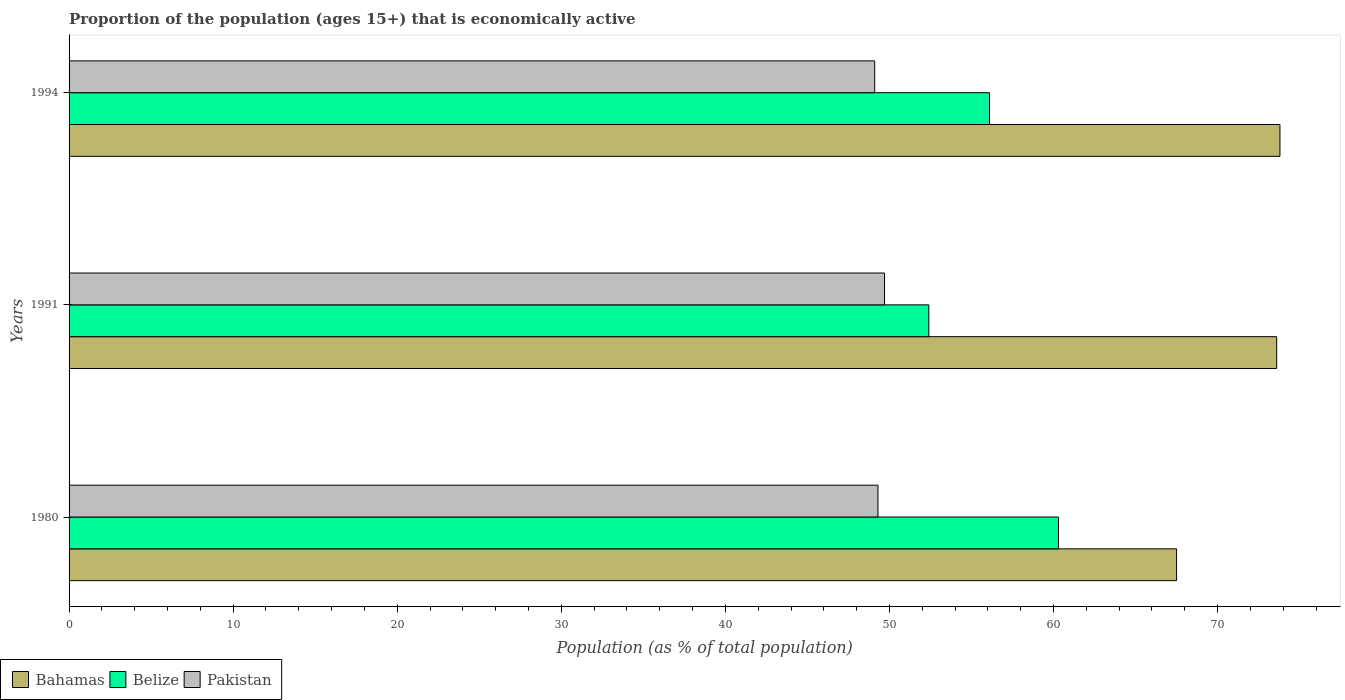How many different coloured bars are there?
Offer a very short reply. 3. Are the number of bars on each tick of the Y-axis equal?
Offer a very short reply. Yes. What is the proportion of the population that is economically active in Bahamas in 1980?
Make the answer very short. 67.5. Across all years, what is the maximum proportion of the population that is economically active in Pakistan?
Provide a short and direct response. 49.7. Across all years, what is the minimum proportion of the population that is economically active in Belize?
Your answer should be compact. 52.4. In which year was the proportion of the population that is economically active in Pakistan minimum?
Your answer should be very brief. 1994. What is the total proportion of the population that is economically active in Pakistan in the graph?
Offer a terse response. 148.1. What is the difference between the proportion of the population that is economically active in Pakistan in 1980 and that in 1994?
Give a very brief answer. 0.2. What is the difference between the proportion of the population that is economically active in Belize in 1980 and the proportion of the population that is economically active in Bahamas in 1991?
Keep it short and to the point. -13.3. What is the average proportion of the population that is economically active in Bahamas per year?
Your answer should be very brief. 71.63. In the year 1980, what is the difference between the proportion of the population that is economically active in Belize and proportion of the population that is economically active in Pakistan?
Provide a short and direct response. 11. What is the ratio of the proportion of the population that is economically active in Pakistan in 1980 to that in 1994?
Your response must be concise. 1. Is the difference between the proportion of the population that is economically active in Belize in 1991 and 1994 greater than the difference between the proportion of the population that is economically active in Pakistan in 1991 and 1994?
Your answer should be very brief. No. What is the difference between the highest and the second highest proportion of the population that is economically active in Bahamas?
Your answer should be very brief. 0.2. What is the difference between the highest and the lowest proportion of the population that is economically active in Pakistan?
Keep it short and to the point. 0.6. What does the 3rd bar from the top in 1991 represents?
Provide a succinct answer. Bahamas. What does the 3rd bar from the bottom in 1994 represents?
Keep it short and to the point. Pakistan. How many bars are there?
Offer a very short reply. 9. How many years are there in the graph?
Provide a succinct answer. 3. Are the values on the major ticks of X-axis written in scientific E-notation?
Ensure brevity in your answer.  No. Does the graph contain any zero values?
Offer a terse response. No. Does the graph contain grids?
Ensure brevity in your answer.  No. Where does the legend appear in the graph?
Ensure brevity in your answer.  Bottom left. How many legend labels are there?
Make the answer very short. 3. How are the legend labels stacked?
Your answer should be compact. Horizontal. What is the title of the graph?
Offer a terse response. Proportion of the population (ages 15+) that is economically active. Does "Jordan" appear as one of the legend labels in the graph?
Ensure brevity in your answer.  No. What is the label or title of the X-axis?
Ensure brevity in your answer.  Population (as % of total population). What is the label or title of the Y-axis?
Give a very brief answer. Years. What is the Population (as % of total population) of Bahamas in 1980?
Make the answer very short. 67.5. What is the Population (as % of total population) in Belize in 1980?
Keep it short and to the point. 60.3. What is the Population (as % of total population) in Pakistan in 1980?
Your answer should be compact. 49.3. What is the Population (as % of total population) in Bahamas in 1991?
Provide a succinct answer. 73.6. What is the Population (as % of total population) of Belize in 1991?
Your response must be concise. 52.4. What is the Population (as % of total population) in Pakistan in 1991?
Ensure brevity in your answer.  49.7. What is the Population (as % of total population) of Bahamas in 1994?
Offer a terse response. 73.8. What is the Population (as % of total population) in Belize in 1994?
Provide a succinct answer. 56.1. What is the Population (as % of total population) in Pakistan in 1994?
Provide a short and direct response. 49.1. Across all years, what is the maximum Population (as % of total population) of Bahamas?
Your answer should be very brief. 73.8. Across all years, what is the maximum Population (as % of total population) of Belize?
Give a very brief answer. 60.3. Across all years, what is the maximum Population (as % of total population) in Pakistan?
Ensure brevity in your answer.  49.7. Across all years, what is the minimum Population (as % of total population) of Bahamas?
Your answer should be very brief. 67.5. Across all years, what is the minimum Population (as % of total population) in Belize?
Offer a very short reply. 52.4. Across all years, what is the minimum Population (as % of total population) in Pakistan?
Your answer should be compact. 49.1. What is the total Population (as % of total population) in Bahamas in the graph?
Your answer should be compact. 214.9. What is the total Population (as % of total population) of Belize in the graph?
Make the answer very short. 168.8. What is the total Population (as % of total population) of Pakistan in the graph?
Provide a short and direct response. 148.1. What is the difference between the Population (as % of total population) in Belize in 1980 and that in 1991?
Your answer should be very brief. 7.9. What is the difference between the Population (as % of total population) in Bahamas in 1980 and that in 1994?
Your answer should be compact. -6.3. What is the difference between the Population (as % of total population) in Bahamas in 1991 and that in 1994?
Offer a very short reply. -0.2. What is the difference between the Population (as % of total population) in Belize in 1991 and that in 1994?
Make the answer very short. -3.7. What is the difference between the Population (as % of total population) of Pakistan in 1991 and that in 1994?
Offer a terse response. 0.6. What is the difference between the Population (as % of total population) in Belize in 1980 and the Population (as % of total population) in Pakistan in 1991?
Your answer should be compact. 10.6. What is the difference between the Population (as % of total population) in Bahamas in 1980 and the Population (as % of total population) in Pakistan in 1994?
Make the answer very short. 18.4. What is the difference between the Population (as % of total population) in Belize in 1980 and the Population (as % of total population) in Pakistan in 1994?
Provide a short and direct response. 11.2. What is the difference between the Population (as % of total population) in Bahamas in 1991 and the Population (as % of total population) in Belize in 1994?
Offer a very short reply. 17.5. What is the average Population (as % of total population) in Bahamas per year?
Offer a terse response. 71.63. What is the average Population (as % of total population) of Belize per year?
Offer a very short reply. 56.27. What is the average Population (as % of total population) of Pakistan per year?
Provide a succinct answer. 49.37. In the year 1980, what is the difference between the Population (as % of total population) of Belize and Population (as % of total population) of Pakistan?
Your answer should be very brief. 11. In the year 1991, what is the difference between the Population (as % of total population) of Bahamas and Population (as % of total population) of Belize?
Offer a very short reply. 21.2. In the year 1991, what is the difference between the Population (as % of total population) of Bahamas and Population (as % of total population) of Pakistan?
Keep it short and to the point. 23.9. In the year 1994, what is the difference between the Population (as % of total population) of Bahamas and Population (as % of total population) of Belize?
Your answer should be very brief. 17.7. In the year 1994, what is the difference between the Population (as % of total population) in Bahamas and Population (as % of total population) in Pakistan?
Make the answer very short. 24.7. What is the ratio of the Population (as % of total population) of Bahamas in 1980 to that in 1991?
Offer a terse response. 0.92. What is the ratio of the Population (as % of total population) of Belize in 1980 to that in 1991?
Your answer should be very brief. 1.15. What is the ratio of the Population (as % of total population) of Bahamas in 1980 to that in 1994?
Your answer should be compact. 0.91. What is the ratio of the Population (as % of total population) in Belize in 1980 to that in 1994?
Provide a short and direct response. 1.07. What is the ratio of the Population (as % of total population) in Belize in 1991 to that in 1994?
Your answer should be very brief. 0.93. What is the ratio of the Population (as % of total population) of Pakistan in 1991 to that in 1994?
Offer a terse response. 1.01. What is the difference between the highest and the second highest Population (as % of total population) of Belize?
Keep it short and to the point. 4.2. What is the difference between the highest and the lowest Population (as % of total population) of Bahamas?
Provide a succinct answer. 6.3. What is the difference between the highest and the lowest Population (as % of total population) in Belize?
Keep it short and to the point. 7.9. 